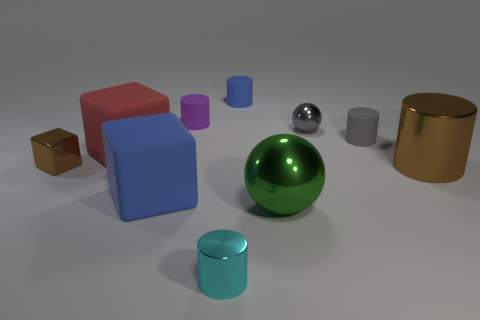How big is the purple cylinder?
Your answer should be very brief. Small. There is a object that is the same color as the metal cube; what shape is it?
Keep it short and to the point. Cylinder. What number of cylinders are either brown shiny things or yellow objects?
Your answer should be compact. 1. Are there an equal number of brown shiny cylinders behind the purple rubber cylinder and blue cylinders that are on the left side of the big blue object?
Your answer should be compact. Yes. What size is the green metallic thing that is the same shape as the small gray shiny thing?
Keep it short and to the point. Large. There is a thing that is both behind the green metallic sphere and in front of the big brown cylinder; how big is it?
Offer a very short reply. Large. There is a purple rubber object; are there any small purple cylinders behind it?
Offer a very short reply. No. How many objects are either blue matte objects to the left of the tiny cyan thing or red rubber things?
Your answer should be compact. 2. How many matte cubes are behind the blue thing right of the cyan metallic cylinder?
Provide a short and direct response. 0. Is the number of large blue matte things that are behind the big brown metal thing less than the number of brown cubes that are behind the tiny brown metal object?
Keep it short and to the point. No. 